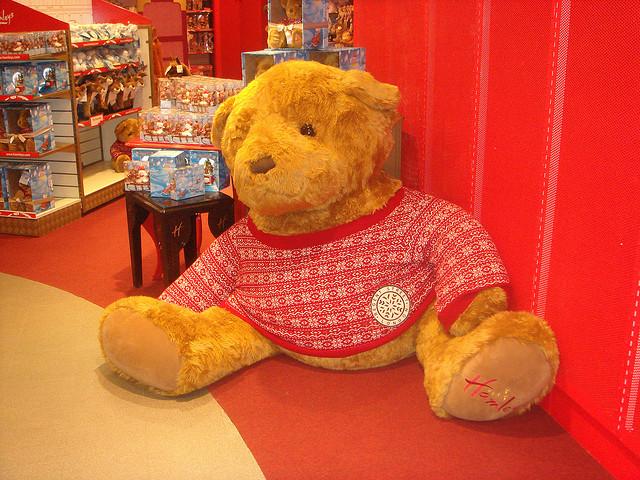Where is the big teddy bear?
Give a very brief answer. Floor. Is this a small or large bear?
Quick response, please. Large. Does the bear have glasses on?
Write a very short answer. No. What color is the circle patch on the sweater?
Concise answer only. White. 